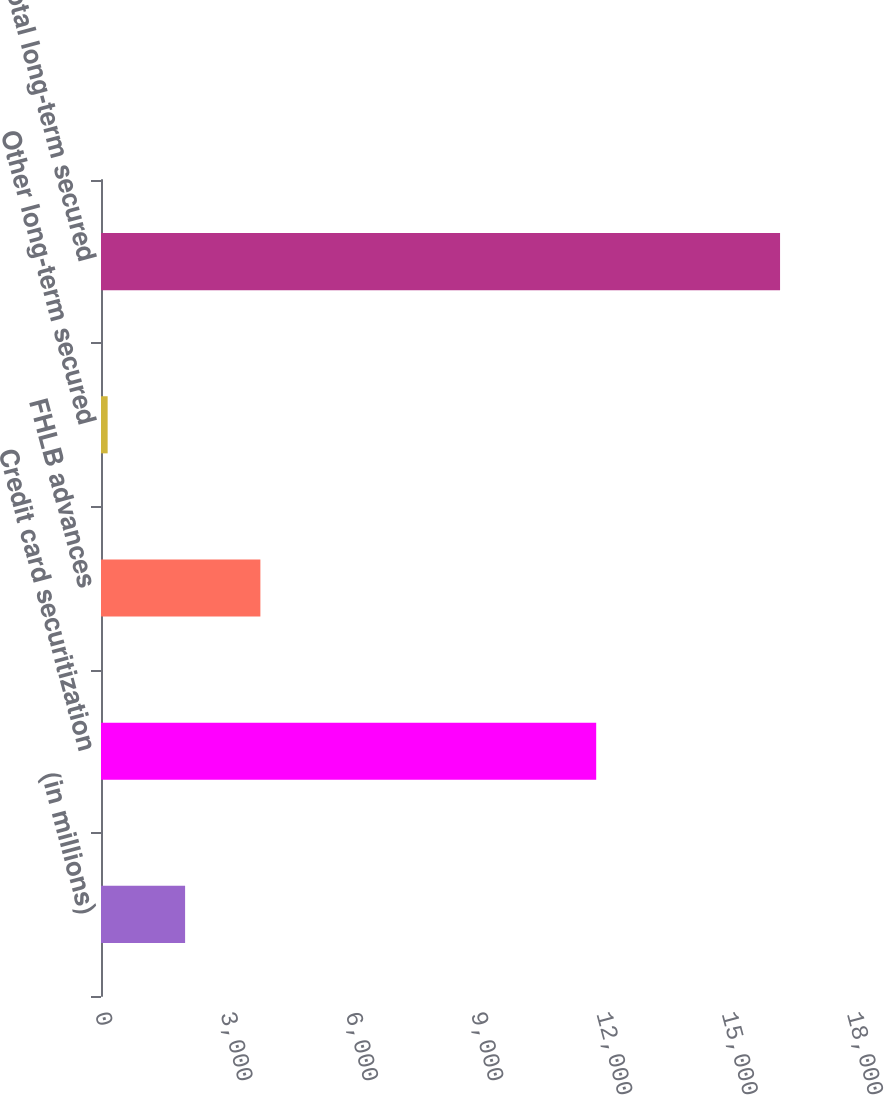Convert chart. <chart><loc_0><loc_0><loc_500><loc_500><bar_chart><fcel>(in millions)<fcel>Credit card securitization<fcel>FHLB advances<fcel>Other long-term secured<fcel>Total long-term secured<nl><fcel>2013<fcel>11853<fcel>3815<fcel>159<fcel>16254<nl></chart> 